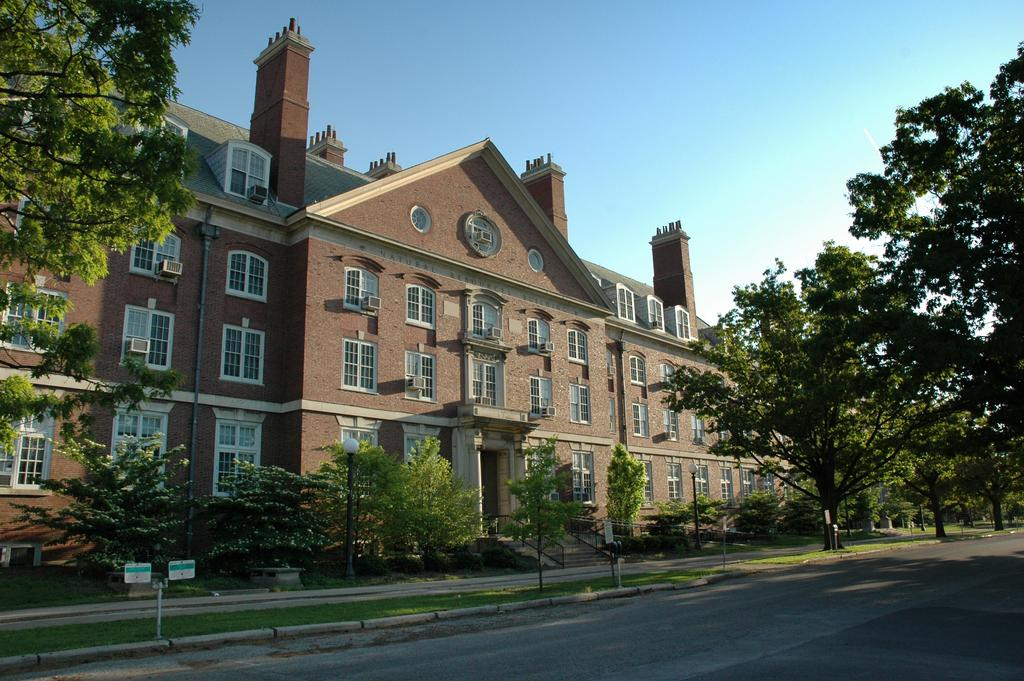What type of structure is present in the image? There is a building in the image. What features can be seen on the building? The building has doors and windows. What type of vegetation is visible in the image? There are trees, plants, and grass in the image. What type of pathway is present in the image? There is a road in the image. What type of vertical structures are present in the image? There are poles and light poles in the image. What part of the natural environment is visible in the image? The sky is visible in the image. What type of behavior can be observed in the earth in the image? There is no behavior observable in the earth, as the earth is not a living entity and cannot exhibit behavior. 